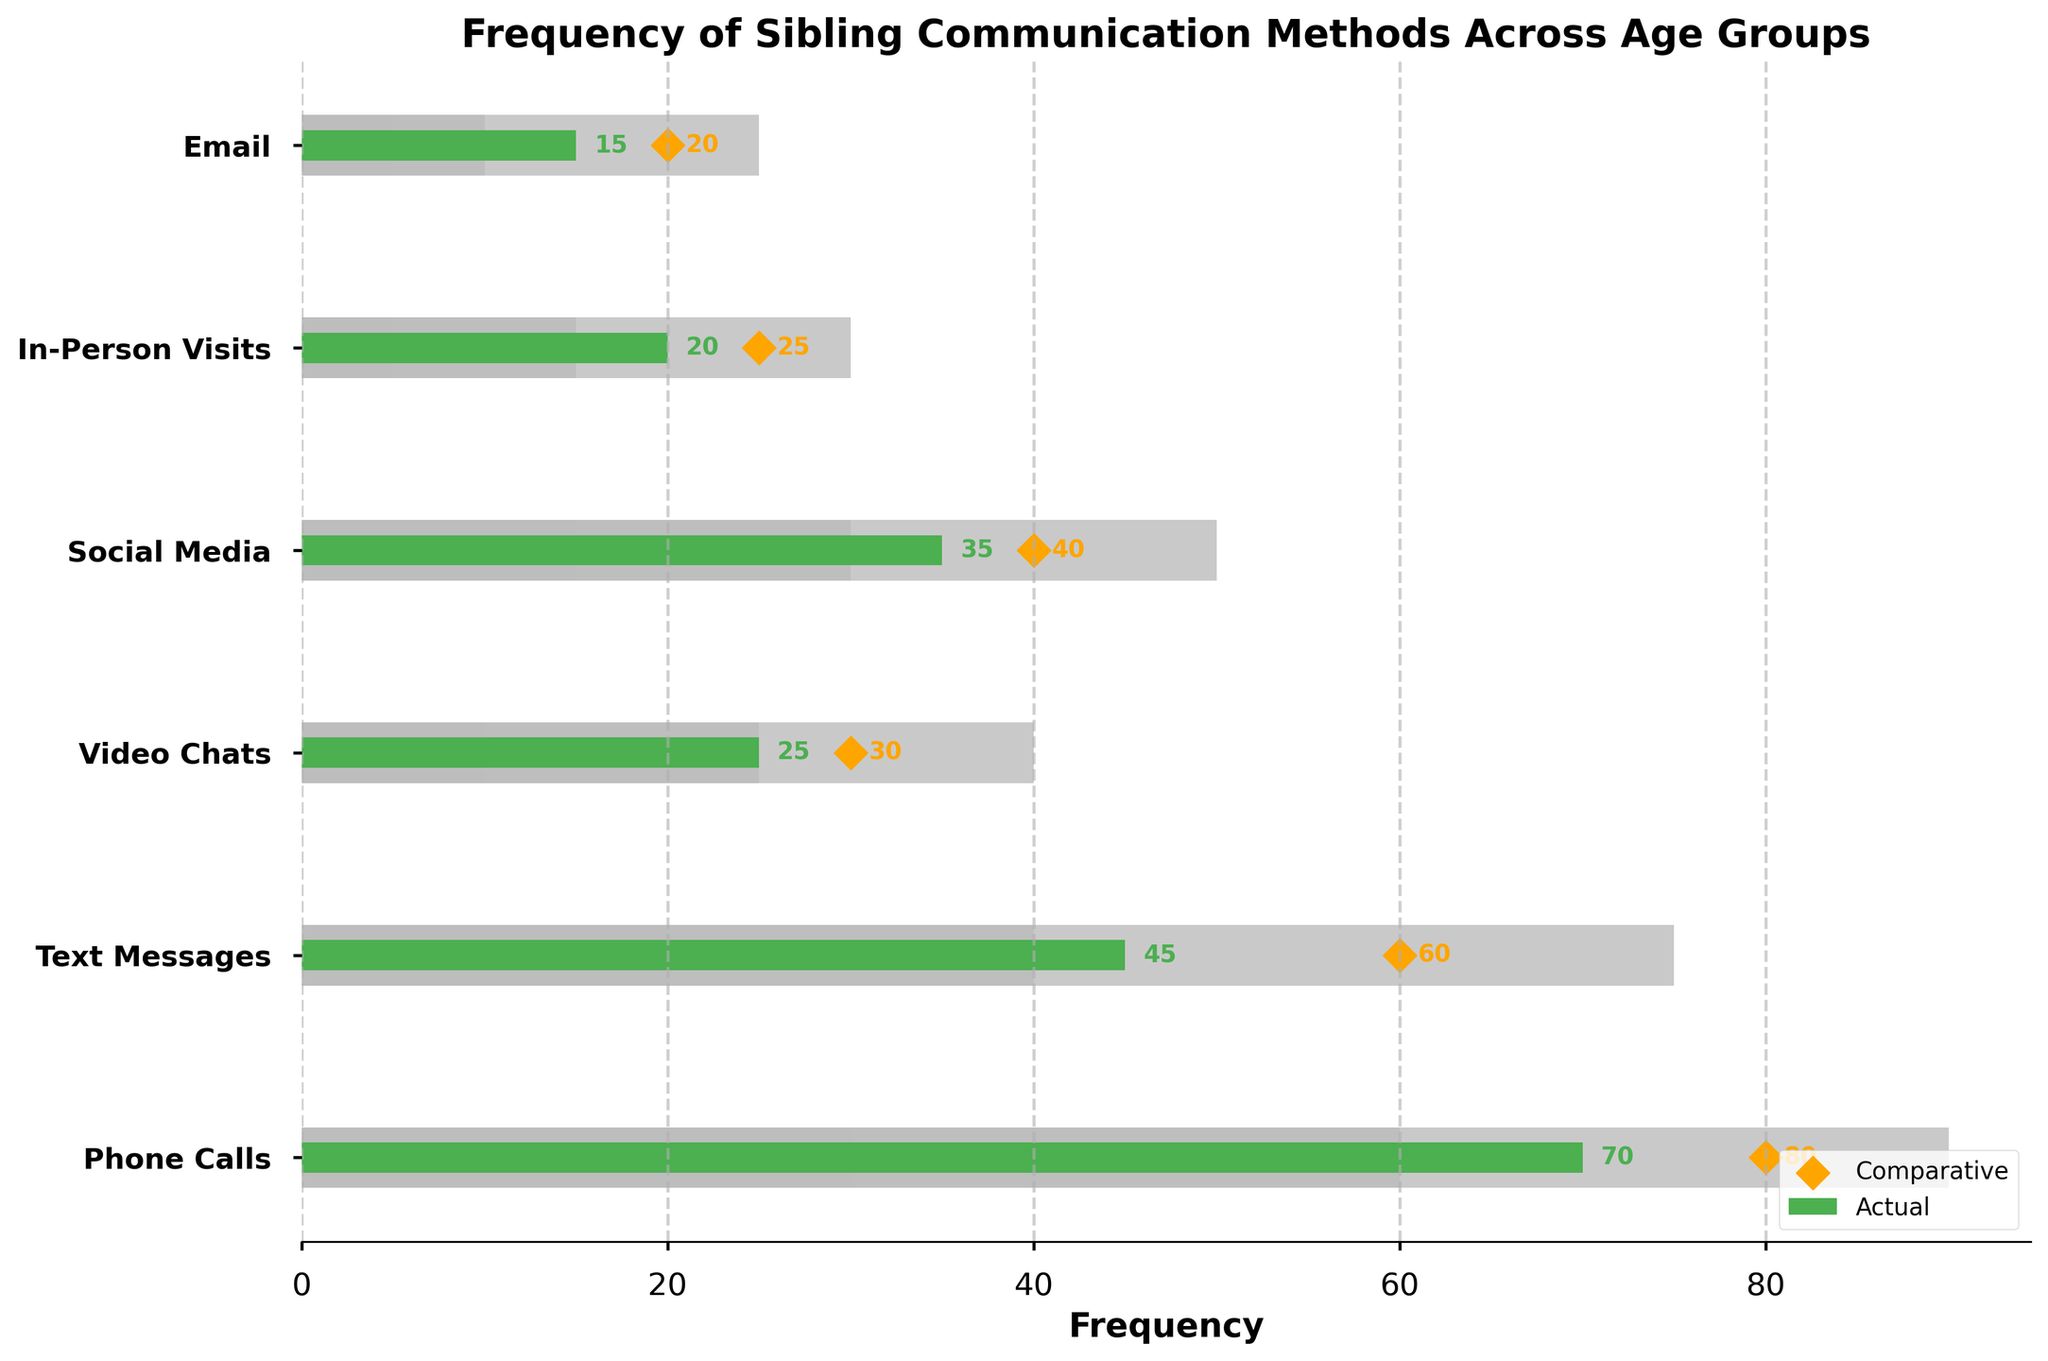What's the most common method of sibling communication according to the 'Actual' values? The 'Actual' values on the figure show the frequencies of different communication methods. The highest 'Actual' value corresponds to phone calls, which is 70.
Answer: Phone Calls Which communication method has the smallest difference between 'Actual' and 'Comparative' values? To find the smallest difference, subtract the 'Actual' values from the 'Comparative' values for each communication method: Phone Calls (80-70=10), Text Messages (60-45=15), Video Chats (30-25=5), Social Media (40-35=5), In-Person Visits (25-20=5), and Email (20-15=5). The smallest difference is observed for Video Chats, Social Media, In-Person Visits, and Email, all with a difference of 5.
Answer: Video Chats, Social Media, In-Person Visits, Email How does the 'Actual' frequency of Text Messages compare to its 'Comparative' value? The 'Actual' frequency of Text Messages is 45, while the 'Comparative' value is 60. Comparing these values shows that the 'Comparative' value is higher than the 'Actual' value.
Answer: The Actual frequency is lower Which communication methods fall within the Range2 thresholds, according to their 'Actual' values? Range2 thresholds apply to methods within specific frequency intervals. For phone calls (30-60), Text Messages (20-40), Video Chats (10-25), Social Media (15-30), In-Person Visits (5-15), and Email (5-10), compare each method's 'Actual' value. Text Messages have 45 and Social Media has 35, both of which fall within the Range2 thresholds.
Answer: Text Messages, Social Media How many communication methods have an 'Actual' frequency below 30? To find this, identify methods with 'Actual' values less than 30: Phone Calls (70), Text Messages (45), Video Chats (25), Social Media (35), In-Person Visits (20), and Email (15). Only Video Chats, In-Person Visits, and Email have 'Actual' frequencies below 30.
Answer: Three methods What's the sum of the 'Actual' frequencies for In-Person Visits and Email? Adding the 'Actual' values for In-Person Visits (20) and Email (15) results in 20 + 15.
Answer: 35 Compare the 'Comparative' value for Phone Calls to that of Social Media. Which is higher? By looking at the 'Comparative' values, Phone Calls have a 'Comparative' value of 80, and Social Media has 40. Therefore, the 'Comparative' value for Phone Calls is higher.
Answer: Phone Calls What can you infer from the height of the bars representing the ranges? The height of the bars represents different thresholds (Range1, Range2, Range3) for each category. The lighter bars denote lower frequencies and the darker ones higher frequencies, revealing how 'Actual' values fit within these ranges.
Answer: Frequency thresholds for each method Is there any communication method where the 'Actual' frequency exactly matches the Range3 upper limit? Checking the 'Actual' values and comparing them with the upper limits of Range3: Phone Calls (90), Text Messages (75), Video Chats (40), Social Media (50), In-Person Visits (30), and Email (25). None of the 'Actual' values exactly match the upper limits of Range3.
Answer: No 